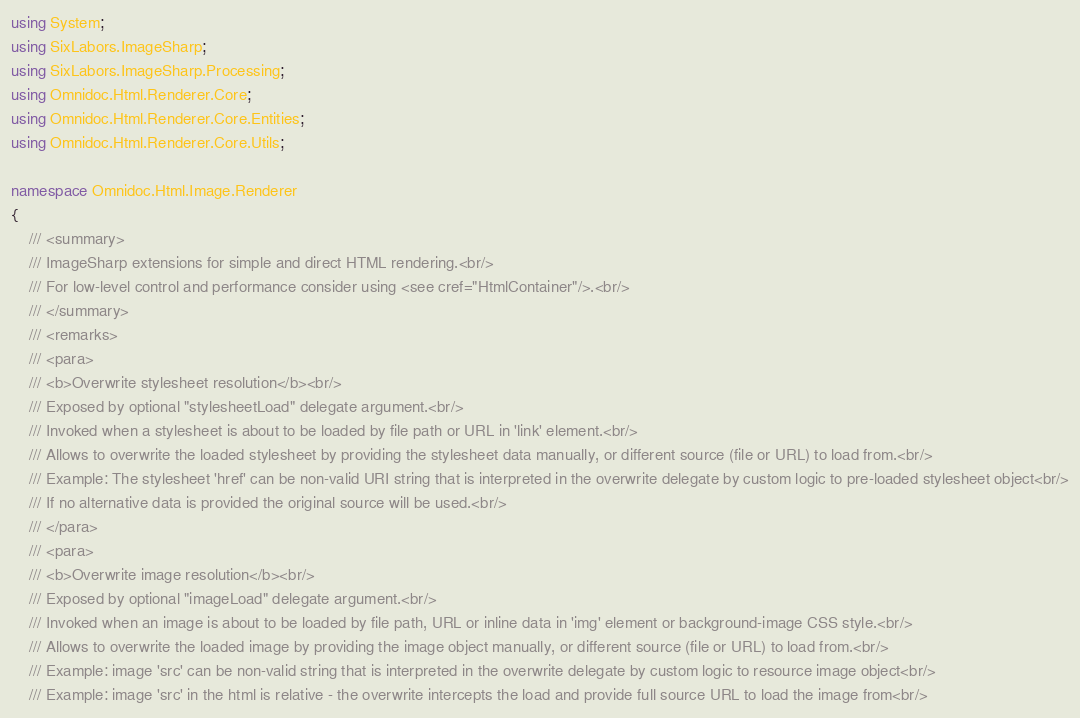Convert code to text. <code><loc_0><loc_0><loc_500><loc_500><_C#_>using System;
using SixLabors.ImageSharp;
using SixLabors.ImageSharp.Processing;
using Omnidoc.Html.Renderer.Core;
using Omnidoc.Html.Renderer.Core.Entities;
using Omnidoc.Html.Renderer.Core.Utils;

namespace Omnidoc.Html.Image.Renderer
{
    /// <summary>
    /// ImageSharp extensions for simple and direct HTML rendering.<br/>
    /// For low-level control and performance consider using <see cref="HtmlContainer"/>.<br/>
    /// </summary>
    /// <remarks>
    /// <para>
    /// <b>Overwrite stylesheet resolution</b><br/>
    /// Exposed by optional "stylesheetLoad" delegate argument.<br/>
    /// Invoked when a stylesheet is about to be loaded by file path or URL in 'link' element.<br/>
    /// Allows to overwrite the loaded stylesheet by providing the stylesheet data manually, or different source (file or URL) to load from.<br/>
    /// Example: The stylesheet 'href' can be non-valid URI string that is interpreted in the overwrite delegate by custom logic to pre-loaded stylesheet object<br/>
    /// If no alternative data is provided the original source will be used.<br/>
    /// </para>
    /// <para>
    /// <b>Overwrite image resolution</b><br/>
    /// Exposed by optional "imageLoad" delegate argument.<br/>
    /// Invoked when an image is about to be loaded by file path, URL or inline data in 'img' element or background-image CSS style.<br/>
    /// Allows to overwrite the loaded image by providing the image object manually, or different source (file or URL) to load from.<br/>
    /// Example: image 'src' can be non-valid string that is interpreted in the overwrite delegate by custom logic to resource image object<br/>
    /// Example: image 'src' in the html is relative - the overwrite intercepts the load and provide full source URL to load the image from<br/></code> 